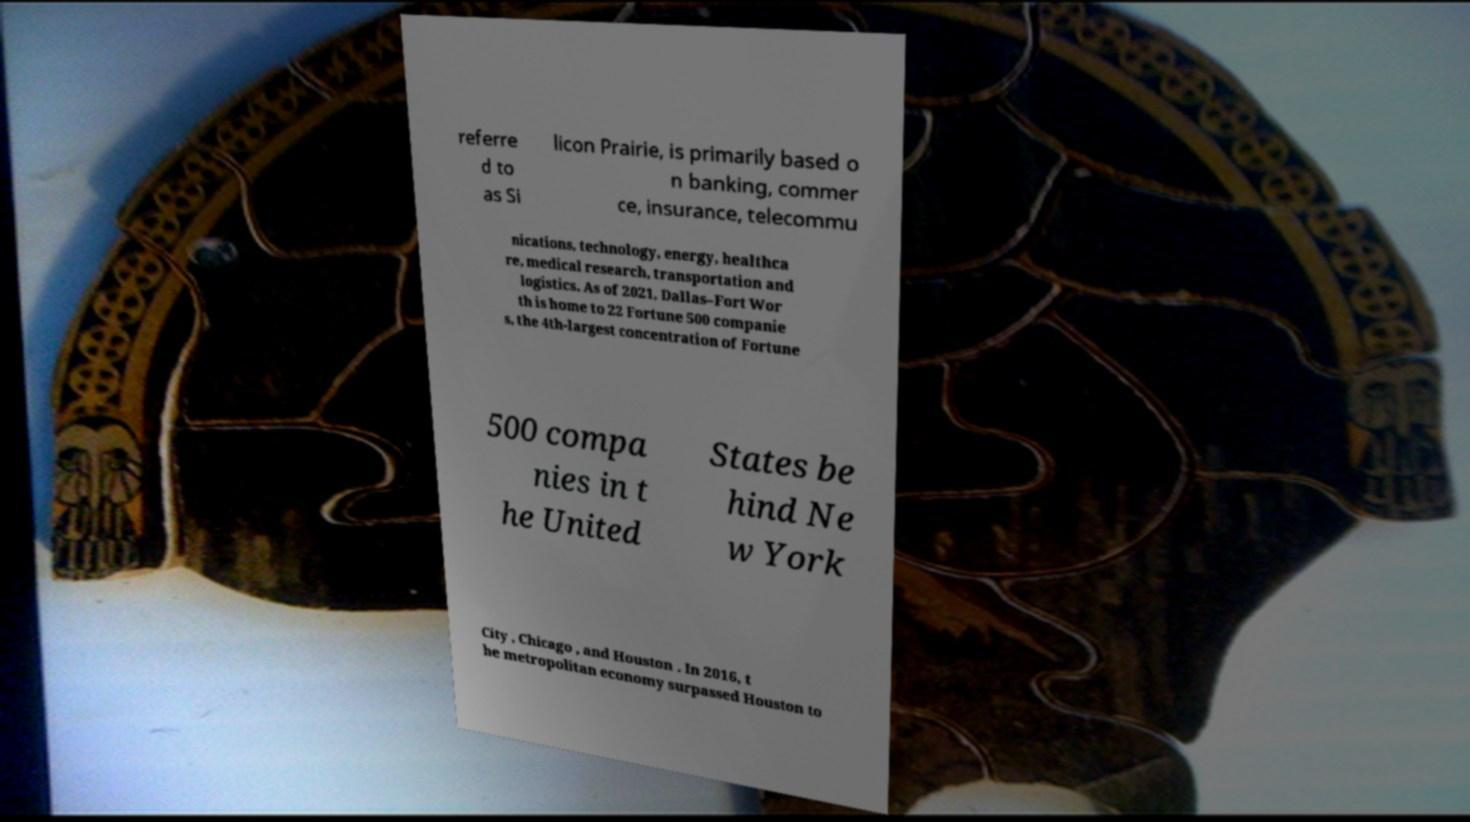For documentation purposes, I need the text within this image transcribed. Could you provide that? referre d to as Si licon Prairie, is primarily based o n banking, commer ce, insurance, telecommu nications, technology, energy, healthca re, medical research, transportation and logistics. As of 2021, Dallas–Fort Wor th is home to 22 Fortune 500 companie s, the 4th-largest concentration of Fortune 500 compa nies in t he United States be hind Ne w York City , Chicago , and Houston . In 2016, t he metropolitan economy surpassed Houston to 